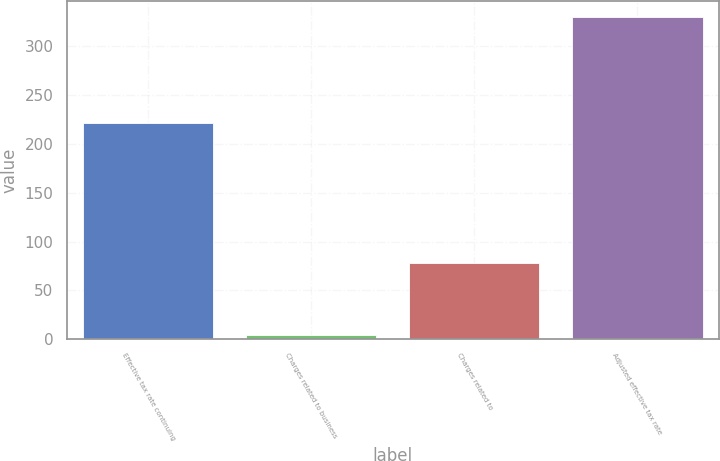<chart> <loc_0><loc_0><loc_500><loc_500><bar_chart><fcel>Effective tax rate continuing<fcel>Charges related to business<fcel>Charges related to<fcel>Adjusted effective tax rate<nl><fcel>221<fcel>4<fcel>77.6<fcel>330<nl></chart> 